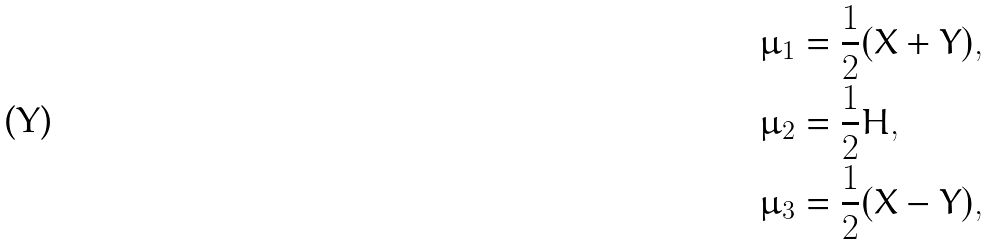<formula> <loc_0><loc_0><loc_500><loc_500>\mu _ { 1 } & = \frac { 1 } { 2 } ( X + Y ) , \\ \mu _ { 2 } & = \frac { 1 } { 2 } H , \\ \mu _ { 3 } & = \frac { 1 } { 2 } ( X - Y ) ,</formula> 